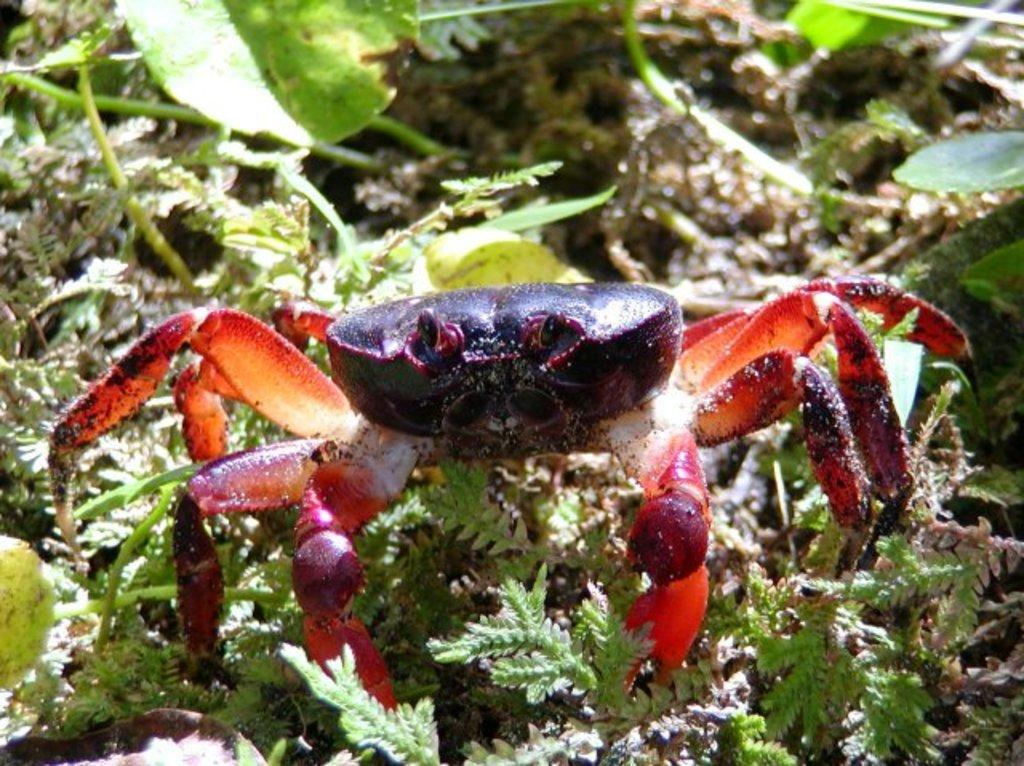What is the main subject in the center of the image? There is a crab in the center of the image. What type of vegetation can be seen in the image? There are plants in the image. What is the ground made of in the image? There is soil visible in the image. How long does it take for the crab to crawl a minute in the image? The concept of time is not applicable to a static image, and there is no indication of the crab's movement in the image. 